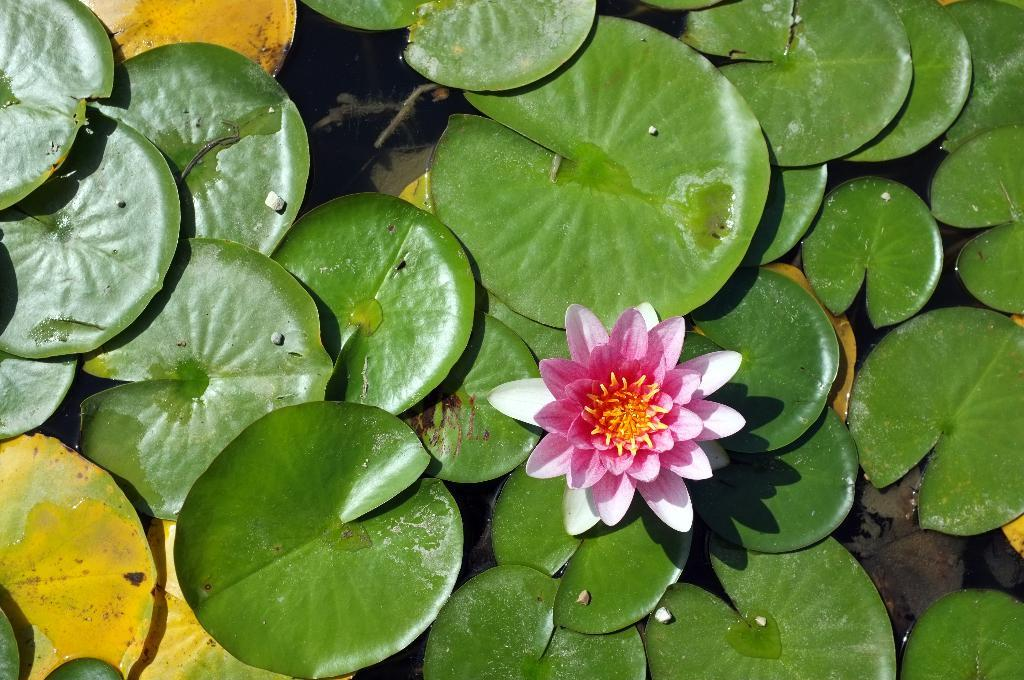What is floating on the water in the image? There are leaves and a flower floating on the water in the image. Can you describe the leaves in the image? The leaves are floating on the water in the image. What else is present in the water besides the leaves? There is a flower floating on the water in the image. What type of holiday is being celebrated in the image? There is no indication of a holiday being celebrated in the image; it features leaves and a flower floating on the water. What color is the linen used to cover the twig in the image? There is no linen or twig present in the image. 